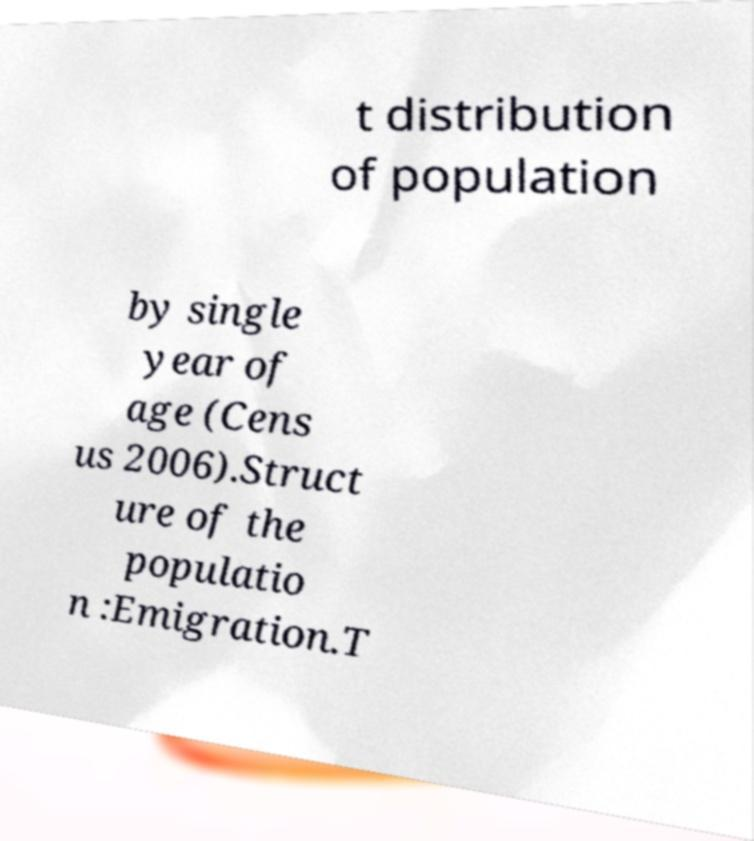I need the written content from this picture converted into text. Can you do that? t distribution of population by single year of age (Cens us 2006).Struct ure of the populatio n :Emigration.T 